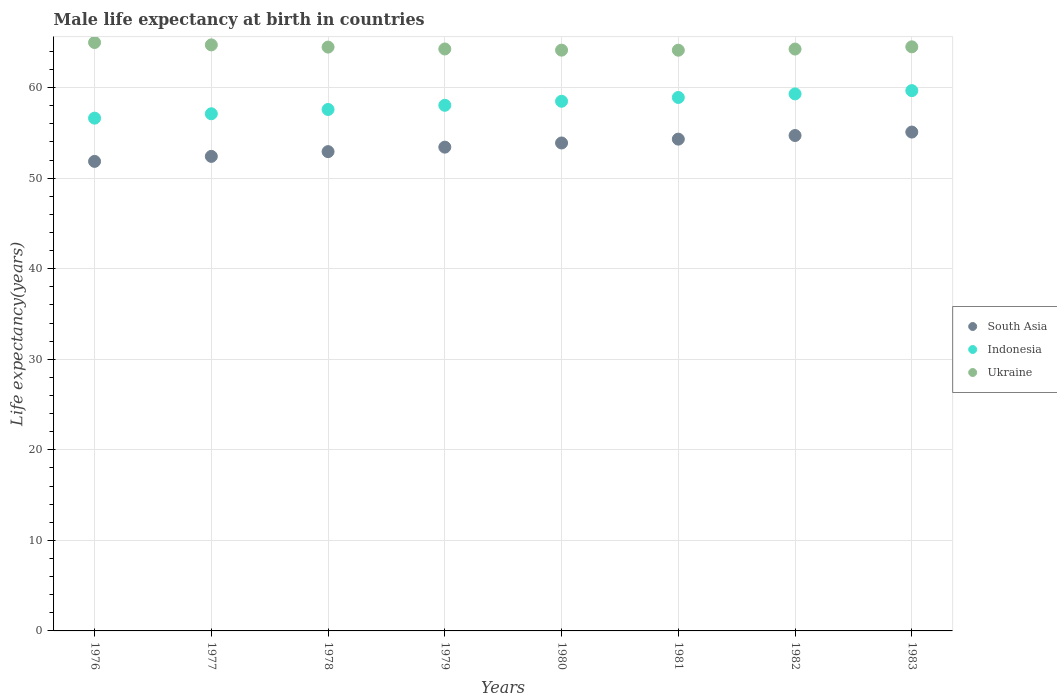How many different coloured dotlines are there?
Make the answer very short. 3. What is the male life expectancy at birth in Ukraine in 1981?
Your answer should be very brief. 64.12. Across all years, what is the maximum male life expectancy at birth in Indonesia?
Provide a short and direct response. 59.66. Across all years, what is the minimum male life expectancy at birth in Ukraine?
Provide a succinct answer. 64.12. What is the total male life expectancy at birth in South Asia in the graph?
Provide a short and direct response. 428.56. What is the difference between the male life expectancy at birth in Ukraine in 1979 and that in 1981?
Provide a short and direct response. 0.14. What is the difference between the male life expectancy at birth in Ukraine in 1983 and the male life expectancy at birth in Indonesia in 1982?
Ensure brevity in your answer.  5.2. What is the average male life expectancy at birth in Ukraine per year?
Offer a very short reply. 64.43. In the year 1977, what is the difference between the male life expectancy at birth in South Asia and male life expectancy at birth in Ukraine?
Provide a succinct answer. -12.31. In how many years, is the male life expectancy at birth in Ukraine greater than 38 years?
Provide a short and direct response. 8. What is the ratio of the male life expectancy at birth in Ukraine in 1979 to that in 1981?
Make the answer very short. 1. Is the male life expectancy at birth in Indonesia in 1980 less than that in 1981?
Your answer should be compact. Yes. Is the difference between the male life expectancy at birth in South Asia in 1979 and 1982 greater than the difference between the male life expectancy at birth in Ukraine in 1979 and 1982?
Your answer should be very brief. No. What is the difference between the highest and the second highest male life expectancy at birth in Ukraine?
Offer a terse response. 0.26. What is the difference between the highest and the lowest male life expectancy at birth in Ukraine?
Ensure brevity in your answer.  0.85. Is the sum of the male life expectancy at birth in Ukraine in 1976 and 1979 greater than the maximum male life expectancy at birth in Indonesia across all years?
Ensure brevity in your answer.  Yes. Is it the case that in every year, the sum of the male life expectancy at birth in Ukraine and male life expectancy at birth in South Asia  is greater than the male life expectancy at birth in Indonesia?
Offer a terse response. Yes. Does the male life expectancy at birth in Indonesia monotonically increase over the years?
Provide a short and direct response. Yes. How many years are there in the graph?
Your response must be concise. 8. Are the values on the major ticks of Y-axis written in scientific E-notation?
Give a very brief answer. No. Does the graph contain any zero values?
Your response must be concise. No. Does the graph contain grids?
Your answer should be compact. Yes. What is the title of the graph?
Ensure brevity in your answer.  Male life expectancy at birth in countries. Does "Romania" appear as one of the legend labels in the graph?
Ensure brevity in your answer.  No. What is the label or title of the X-axis?
Provide a short and direct response. Years. What is the label or title of the Y-axis?
Provide a short and direct response. Life expectancy(years). What is the Life expectancy(years) of South Asia in 1976?
Ensure brevity in your answer.  51.85. What is the Life expectancy(years) of Indonesia in 1976?
Your answer should be compact. 56.62. What is the Life expectancy(years) of Ukraine in 1976?
Ensure brevity in your answer.  64.97. What is the Life expectancy(years) in South Asia in 1977?
Ensure brevity in your answer.  52.4. What is the Life expectancy(years) of Indonesia in 1977?
Make the answer very short. 57.1. What is the Life expectancy(years) of Ukraine in 1977?
Keep it short and to the point. 64.71. What is the Life expectancy(years) of South Asia in 1978?
Provide a short and direct response. 52.92. What is the Life expectancy(years) in Indonesia in 1978?
Give a very brief answer. 57.58. What is the Life expectancy(years) in Ukraine in 1978?
Offer a terse response. 64.47. What is the Life expectancy(years) of South Asia in 1979?
Provide a short and direct response. 53.42. What is the Life expectancy(years) in Indonesia in 1979?
Offer a terse response. 58.04. What is the Life expectancy(years) of Ukraine in 1979?
Your answer should be compact. 64.26. What is the Life expectancy(years) in South Asia in 1980?
Provide a succinct answer. 53.88. What is the Life expectancy(years) in Indonesia in 1980?
Keep it short and to the point. 58.49. What is the Life expectancy(years) in Ukraine in 1980?
Ensure brevity in your answer.  64.13. What is the Life expectancy(years) in South Asia in 1981?
Keep it short and to the point. 54.3. What is the Life expectancy(years) in Indonesia in 1981?
Give a very brief answer. 58.91. What is the Life expectancy(years) of Ukraine in 1981?
Ensure brevity in your answer.  64.12. What is the Life expectancy(years) in South Asia in 1982?
Your answer should be compact. 54.7. What is the Life expectancy(years) in Indonesia in 1982?
Your response must be concise. 59.3. What is the Life expectancy(years) of Ukraine in 1982?
Your answer should be very brief. 64.25. What is the Life expectancy(years) of South Asia in 1983?
Provide a succinct answer. 55.08. What is the Life expectancy(years) of Indonesia in 1983?
Provide a succinct answer. 59.66. What is the Life expectancy(years) of Ukraine in 1983?
Make the answer very short. 64.5. Across all years, what is the maximum Life expectancy(years) of South Asia?
Provide a short and direct response. 55.08. Across all years, what is the maximum Life expectancy(years) in Indonesia?
Keep it short and to the point. 59.66. Across all years, what is the maximum Life expectancy(years) in Ukraine?
Your answer should be very brief. 64.97. Across all years, what is the minimum Life expectancy(years) in South Asia?
Provide a short and direct response. 51.85. Across all years, what is the minimum Life expectancy(years) of Indonesia?
Your answer should be very brief. 56.62. Across all years, what is the minimum Life expectancy(years) of Ukraine?
Ensure brevity in your answer.  64.12. What is the total Life expectancy(years) of South Asia in the graph?
Offer a terse response. 428.56. What is the total Life expectancy(years) in Indonesia in the graph?
Provide a succinct answer. 465.7. What is the total Life expectancy(years) in Ukraine in the graph?
Offer a terse response. 515.41. What is the difference between the Life expectancy(years) of South Asia in 1976 and that in 1977?
Provide a succinct answer. -0.55. What is the difference between the Life expectancy(years) of Indonesia in 1976 and that in 1977?
Make the answer very short. -0.48. What is the difference between the Life expectancy(years) of Ukraine in 1976 and that in 1977?
Provide a short and direct response. 0.26. What is the difference between the Life expectancy(years) of South Asia in 1976 and that in 1978?
Ensure brevity in your answer.  -1.08. What is the difference between the Life expectancy(years) in Indonesia in 1976 and that in 1978?
Your answer should be very brief. -0.96. What is the difference between the Life expectancy(years) in Ukraine in 1976 and that in 1978?
Your answer should be very brief. 0.51. What is the difference between the Life expectancy(years) of South Asia in 1976 and that in 1979?
Your answer should be very brief. -1.57. What is the difference between the Life expectancy(years) in Indonesia in 1976 and that in 1979?
Provide a short and direct response. -1.42. What is the difference between the Life expectancy(years) of Ukraine in 1976 and that in 1979?
Your answer should be very brief. 0.71. What is the difference between the Life expectancy(years) in South Asia in 1976 and that in 1980?
Provide a succinct answer. -2.03. What is the difference between the Life expectancy(years) of Indonesia in 1976 and that in 1980?
Offer a terse response. -1.86. What is the difference between the Life expectancy(years) of Ukraine in 1976 and that in 1980?
Offer a terse response. 0.84. What is the difference between the Life expectancy(years) of South Asia in 1976 and that in 1981?
Give a very brief answer. -2.46. What is the difference between the Life expectancy(years) in Indonesia in 1976 and that in 1981?
Ensure brevity in your answer.  -2.29. What is the difference between the Life expectancy(years) of Ukraine in 1976 and that in 1981?
Offer a very short reply. 0.85. What is the difference between the Life expectancy(years) in South Asia in 1976 and that in 1982?
Your answer should be very brief. -2.86. What is the difference between the Life expectancy(years) of Indonesia in 1976 and that in 1982?
Your answer should be compact. -2.68. What is the difference between the Life expectancy(years) of Ukraine in 1976 and that in 1982?
Give a very brief answer. 0.72. What is the difference between the Life expectancy(years) of South Asia in 1976 and that in 1983?
Make the answer very short. -3.24. What is the difference between the Life expectancy(years) of Indonesia in 1976 and that in 1983?
Ensure brevity in your answer.  -3.04. What is the difference between the Life expectancy(years) of Ukraine in 1976 and that in 1983?
Your response must be concise. 0.48. What is the difference between the Life expectancy(years) of South Asia in 1977 and that in 1978?
Ensure brevity in your answer.  -0.53. What is the difference between the Life expectancy(years) of Indonesia in 1977 and that in 1978?
Make the answer very short. -0.47. What is the difference between the Life expectancy(years) of Ukraine in 1977 and that in 1978?
Offer a terse response. 0.24. What is the difference between the Life expectancy(years) in South Asia in 1977 and that in 1979?
Offer a very short reply. -1.02. What is the difference between the Life expectancy(years) of Indonesia in 1977 and that in 1979?
Your answer should be compact. -0.94. What is the difference between the Life expectancy(years) of Ukraine in 1977 and that in 1979?
Make the answer very short. 0.45. What is the difference between the Life expectancy(years) in South Asia in 1977 and that in 1980?
Your answer should be very brief. -1.48. What is the difference between the Life expectancy(years) of Indonesia in 1977 and that in 1980?
Keep it short and to the point. -1.38. What is the difference between the Life expectancy(years) in Ukraine in 1977 and that in 1980?
Keep it short and to the point. 0.58. What is the difference between the Life expectancy(years) in South Asia in 1977 and that in 1981?
Offer a very short reply. -1.9. What is the difference between the Life expectancy(years) of Indonesia in 1977 and that in 1981?
Offer a terse response. -1.8. What is the difference between the Life expectancy(years) of Ukraine in 1977 and that in 1981?
Keep it short and to the point. 0.59. What is the difference between the Life expectancy(years) in South Asia in 1977 and that in 1982?
Give a very brief answer. -2.3. What is the difference between the Life expectancy(years) of Indonesia in 1977 and that in 1982?
Offer a terse response. -2.19. What is the difference between the Life expectancy(years) in Ukraine in 1977 and that in 1982?
Provide a short and direct response. 0.46. What is the difference between the Life expectancy(years) of South Asia in 1977 and that in 1983?
Provide a succinct answer. -2.69. What is the difference between the Life expectancy(years) in Indonesia in 1977 and that in 1983?
Provide a succinct answer. -2.56. What is the difference between the Life expectancy(years) in Ukraine in 1977 and that in 1983?
Make the answer very short. 0.21. What is the difference between the Life expectancy(years) in South Asia in 1978 and that in 1979?
Provide a short and direct response. -0.49. What is the difference between the Life expectancy(years) in Indonesia in 1978 and that in 1979?
Make the answer very short. -0.46. What is the difference between the Life expectancy(years) in Ukraine in 1978 and that in 1979?
Your response must be concise. 0.21. What is the difference between the Life expectancy(years) of South Asia in 1978 and that in 1980?
Your answer should be very brief. -0.96. What is the difference between the Life expectancy(years) of Indonesia in 1978 and that in 1980?
Ensure brevity in your answer.  -0.91. What is the difference between the Life expectancy(years) in Ukraine in 1978 and that in 1980?
Ensure brevity in your answer.  0.34. What is the difference between the Life expectancy(years) in South Asia in 1978 and that in 1981?
Keep it short and to the point. -1.38. What is the difference between the Life expectancy(years) of Indonesia in 1978 and that in 1981?
Your answer should be very brief. -1.33. What is the difference between the Life expectancy(years) in Ukraine in 1978 and that in 1981?
Your answer should be very brief. 0.34. What is the difference between the Life expectancy(years) of South Asia in 1978 and that in 1982?
Your answer should be compact. -1.78. What is the difference between the Life expectancy(years) of Indonesia in 1978 and that in 1982?
Offer a very short reply. -1.72. What is the difference between the Life expectancy(years) of Ukraine in 1978 and that in 1982?
Provide a short and direct response. 0.22. What is the difference between the Life expectancy(years) of South Asia in 1978 and that in 1983?
Give a very brief answer. -2.16. What is the difference between the Life expectancy(years) in Indonesia in 1978 and that in 1983?
Provide a short and direct response. -2.08. What is the difference between the Life expectancy(years) of Ukraine in 1978 and that in 1983?
Your response must be concise. -0.03. What is the difference between the Life expectancy(years) in South Asia in 1979 and that in 1980?
Ensure brevity in your answer.  -0.46. What is the difference between the Life expectancy(years) of Indonesia in 1979 and that in 1980?
Provide a succinct answer. -0.45. What is the difference between the Life expectancy(years) of Ukraine in 1979 and that in 1980?
Your answer should be compact. 0.13. What is the difference between the Life expectancy(years) in South Asia in 1979 and that in 1981?
Ensure brevity in your answer.  -0.88. What is the difference between the Life expectancy(years) in Indonesia in 1979 and that in 1981?
Your answer should be compact. -0.86. What is the difference between the Life expectancy(years) of Ukraine in 1979 and that in 1981?
Provide a short and direct response. 0.14. What is the difference between the Life expectancy(years) of South Asia in 1979 and that in 1982?
Your answer should be very brief. -1.28. What is the difference between the Life expectancy(years) in Indonesia in 1979 and that in 1982?
Your answer should be very brief. -1.26. What is the difference between the Life expectancy(years) in Ukraine in 1979 and that in 1982?
Keep it short and to the point. 0.01. What is the difference between the Life expectancy(years) in South Asia in 1979 and that in 1983?
Your answer should be very brief. -1.67. What is the difference between the Life expectancy(years) of Indonesia in 1979 and that in 1983?
Provide a short and direct response. -1.62. What is the difference between the Life expectancy(years) of Ukraine in 1979 and that in 1983?
Offer a very short reply. -0.24. What is the difference between the Life expectancy(years) in South Asia in 1980 and that in 1981?
Offer a terse response. -0.42. What is the difference between the Life expectancy(years) in Indonesia in 1980 and that in 1981?
Provide a succinct answer. -0.42. What is the difference between the Life expectancy(years) in Ukraine in 1980 and that in 1981?
Offer a terse response. 0.01. What is the difference between the Life expectancy(years) of South Asia in 1980 and that in 1982?
Offer a very short reply. -0.82. What is the difference between the Life expectancy(years) of Indonesia in 1980 and that in 1982?
Give a very brief answer. -0.81. What is the difference between the Life expectancy(years) in Ukraine in 1980 and that in 1982?
Your answer should be compact. -0.12. What is the difference between the Life expectancy(years) in South Asia in 1980 and that in 1983?
Keep it short and to the point. -1.2. What is the difference between the Life expectancy(years) in Indonesia in 1980 and that in 1983?
Your answer should be compact. -1.18. What is the difference between the Life expectancy(years) of Ukraine in 1980 and that in 1983?
Provide a short and direct response. -0.37. What is the difference between the Life expectancy(years) of South Asia in 1981 and that in 1982?
Provide a short and direct response. -0.4. What is the difference between the Life expectancy(years) of Indonesia in 1981 and that in 1982?
Offer a very short reply. -0.39. What is the difference between the Life expectancy(years) in Ukraine in 1981 and that in 1982?
Provide a succinct answer. -0.13. What is the difference between the Life expectancy(years) in South Asia in 1981 and that in 1983?
Keep it short and to the point. -0.78. What is the difference between the Life expectancy(years) of Indonesia in 1981 and that in 1983?
Your answer should be compact. -0.76. What is the difference between the Life expectancy(years) of Ukraine in 1981 and that in 1983?
Provide a short and direct response. -0.37. What is the difference between the Life expectancy(years) in South Asia in 1982 and that in 1983?
Keep it short and to the point. -0.38. What is the difference between the Life expectancy(years) of Indonesia in 1982 and that in 1983?
Your answer should be very brief. -0.36. What is the difference between the Life expectancy(years) in Ukraine in 1982 and that in 1983?
Give a very brief answer. -0.25. What is the difference between the Life expectancy(years) in South Asia in 1976 and the Life expectancy(years) in Indonesia in 1977?
Ensure brevity in your answer.  -5.26. What is the difference between the Life expectancy(years) of South Asia in 1976 and the Life expectancy(years) of Ukraine in 1977?
Your answer should be very brief. -12.86. What is the difference between the Life expectancy(years) of Indonesia in 1976 and the Life expectancy(years) of Ukraine in 1977?
Your answer should be very brief. -8.09. What is the difference between the Life expectancy(years) of South Asia in 1976 and the Life expectancy(years) of Indonesia in 1978?
Your answer should be very brief. -5.73. What is the difference between the Life expectancy(years) in South Asia in 1976 and the Life expectancy(years) in Ukraine in 1978?
Offer a terse response. -12.62. What is the difference between the Life expectancy(years) of Indonesia in 1976 and the Life expectancy(years) of Ukraine in 1978?
Ensure brevity in your answer.  -7.85. What is the difference between the Life expectancy(years) of South Asia in 1976 and the Life expectancy(years) of Indonesia in 1979?
Provide a succinct answer. -6.19. What is the difference between the Life expectancy(years) in South Asia in 1976 and the Life expectancy(years) in Ukraine in 1979?
Your response must be concise. -12.41. What is the difference between the Life expectancy(years) of Indonesia in 1976 and the Life expectancy(years) of Ukraine in 1979?
Your answer should be compact. -7.64. What is the difference between the Life expectancy(years) in South Asia in 1976 and the Life expectancy(years) in Indonesia in 1980?
Offer a very short reply. -6.64. What is the difference between the Life expectancy(years) of South Asia in 1976 and the Life expectancy(years) of Ukraine in 1980?
Provide a short and direct response. -12.28. What is the difference between the Life expectancy(years) of Indonesia in 1976 and the Life expectancy(years) of Ukraine in 1980?
Ensure brevity in your answer.  -7.51. What is the difference between the Life expectancy(years) in South Asia in 1976 and the Life expectancy(years) in Indonesia in 1981?
Offer a very short reply. -7.06. What is the difference between the Life expectancy(years) of South Asia in 1976 and the Life expectancy(years) of Ukraine in 1981?
Your answer should be very brief. -12.28. What is the difference between the Life expectancy(years) of Indonesia in 1976 and the Life expectancy(years) of Ukraine in 1981?
Make the answer very short. -7.5. What is the difference between the Life expectancy(years) of South Asia in 1976 and the Life expectancy(years) of Indonesia in 1982?
Provide a succinct answer. -7.45. What is the difference between the Life expectancy(years) of South Asia in 1976 and the Life expectancy(years) of Ukraine in 1982?
Give a very brief answer. -12.4. What is the difference between the Life expectancy(years) in Indonesia in 1976 and the Life expectancy(years) in Ukraine in 1982?
Offer a terse response. -7.63. What is the difference between the Life expectancy(years) of South Asia in 1976 and the Life expectancy(years) of Indonesia in 1983?
Your answer should be compact. -7.81. What is the difference between the Life expectancy(years) in South Asia in 1976 and the Life expectancy(years) in Ukraine in 1983?
Offer a terse response. -12.65. What is the difference between the Life expectancy(years) of Indonesia in 1976 and the Life expectancy(years) of Ukraine in 1983?
Your response must be concise. -7.88. What is the difference between the Life expectancy(years) of South Asia in 1977 and the Life expectancy(years) of Indonesia in 1978?
Provide a short and direct response. -5.18. What is the difference between the Life expectancy(years) of South Asia in 1977 and the Life expectancy(years) of Ukraine in 1978?
Provide a short and direct response. -12.07. What is the difference between the Life expectancy(years) of Indonesia in 1977 and the Life expectancy(years) of Ukraine in 1978?
Offer a terse response. -7.36. What is the difference between the Life expectancy(years) in South Asia in 1977 and the Life expectancy(years) in Indonesia in 1979?
Your response must be concise. -5.64. What is the difference between the Life expectancy(years) in South Asia in 1977 and the Life expectancy(years) in Ukraine in 1979?
Offer a terse response. -11.86. What is the difference between the Life expectancy(years) of Indonesia in 1977 and the Life expectancy(years) of Ukraine in 1979?
Make the answer very short. -7.16. What is the difference between the Life expectancy(years) of South Asia in 1977 and the Life expectancy(years) of Indonesia in 1980?
Make the answer very short. -6.09. What is the difference between the Life expectancy(years) in South Asia in 1977 and the Life expectancy(years) in Ukraine in 1980?
Keep it short and to the point. -11.73. What is the difference between the Life expectancy(years) in Indonesia in 1977 and the Life expectancy(years) in Ukraine in 1980?
Ensure brevity in your answer.  -7.03. What is the difference between the Life expectancy(years) of South Asia in 1977 and the Life expectancy(years) of Indonesia in 1981?
Provide a succinct answer. -6.51. What is the difference between the Life expectancy(years) of South Asia in 1977 and the Life expectancy(years) of Ukraine in 1981?
Make the answer very short. -11.72. What is the difference between the Life expectancy(years) in Indonesia in 1977 and the Life expectancy(years) in Ukraine in 1981?
Offer a terse response. -7.02. What is the difference between the Life expectancy(years) of South Asia in 1977 and the Life expectancy(years) of Indonesia in 1982?
Your answer should be compact. -6.9. What is the difference between the Life expectancy(years) in South Asia in 1977 and the Life expectancy(years) in Ukraine in 1982?
Give a very brief answer. -11.85. What is the difference between the Life expectancy(years) of Indonesia in 1977 and the Life expectancy(years) of Ukraine in 1982?
Make the answer very short. -7.15. What is the difference between the Life expectancy(years) of South Asia in 1977 and the Life expectancy(years) of Indonesia in 1983?
Offer a terse response. -7.26. What is the difference between the Life expectancy(years) in South Asia in 1977 and the Life expectancy(years) in Ukraine in 1983?
Ensure brevity in your answer.  -12.1. What is the difference between the Life expectancy(years) of Indonesia in 1977 and the Life expectancy(years) of Ukraine in 1983?
Your answer should be very brief. -7.39. What is the difference between the Life expectancy(years) in South Asia in 1978 and the Life expectancy(years) in Indonesia in 1979?
Offer a very short reply. -5.12. What is the difference between the Life expectancy(years) in South Asia in 1978 and the Life expectancy(years) in Ukraine in 1979?
Your answer should be compact. -11.34. What is the difference between the Life expectancy(years) in Indonesia in 1978 and the Life expectancy(years) in Ukraine in 1979?
Your response must be concise. -6.68. What is the difference between the Life expectancy(years) of South Asia in 1978 and the Life expectancy(years) of Indonesia in 1980?
Provide a succinct answer. -5.56. What is the difference between the Life expectancy(years) of South Asia in 1978 and the Life expectancy(years) of Ukraine in 1980?
Ensure brevity in your answer.  -11.21. What is the difference between the Life expectancy(years) in Indonesia in 1978 and the Life expectancy(years) in Ukraine in 1980?
Your answer should be compact. -6.55. What is the difference between the Life expectancy(years) of South Asia in 1978 and the Life expectancy(years) of Indonesia in 1981?
Keep it short and to the point. -5.98. What is the difference between the Life expectancy(years) of South Asia in 1978 and the Life expectancy(years) of Ukraine in 1981?
Make the answer very short. -11.2. What is the difference between the Life expectancy(years) in Indonesia in 1978 and the Life expectancy(years) in Ukraine in 1981?
Make the answer very short. -6.54. What is the difference between the Life expectancy(years) in South Asia in 1978 and the Life expectancy(years) in Indonesia in 1982?
Make the answer very short. -6.37. What is the difference between the Life expectancy(years) of South Asia in 1978 and the Life expectancy(years) of Ukraine in 1982?
Make the answer very short. -11.33. What is the difference between the Life expectancy(years) in Indonesia in 1978 and the Life expectancy(years) in Ukraine in 1982?
Provide a short and direct response. -6.67. What is the difference between the Life expectancy(years) in South Asia in 1978 and the Life expectancy(years) in Indonesia in 1983?
Give a very brief answer. -6.74. What is the difference between the Life expectancy(years) of South Asia in 1978 and the Life expectancy(years) of Ukraine in 1983?
Keep it short and to the point. -11.57. What is the difference between the Life expectancy(years) in Indonesia in 1978 and the Life expectancy(years) in Ukraine in 1983?
Give a very brief answer. -6.92. What is the difference between the Life expectancy(years) of South Asia in 1979 and the Life expectancy(years) of Indonesia in 1980?
Ensure brevity in your answer.  -5.07. What is the difference between the Life expectancy(years) in South Asia in 1979 and the Life expectancy(years) in Ukraine in 1980?
Ensure brevity in your answer.  -10.71. What is the difference between the Life expectancy(years) of Indonesia in 1979 and the Life expectancy(years) of Ukraine in 1980?
Offer a very short reply. -6.09. What is the difference between the Life expectancy(years) in South Asia in 1979 and the Life expectancy(years) in Indonesia in 1981?
Keep it short and to the point. -5.49. What is the difference between the Life expectancy(years) of South Asia in 1979 and the Life expectancy(years) of Ukraine in 1981?
Your answer should be compact. -10.7. What is the difference between the Life expectancy(years) in Indonesia in 1979 and the Life expectancy(years) in Ukraine in 1981?
Ensure brevity in your answer.  -6.08. What is the difference between the Life expectancy(years) of South Asia in 1979 and the Life expectancy(years) of Indonesia in 1982?
Give a very brief answer. -5.88. What is the difference between the Life expectancy(years) in South Asia in 1979 and the Life expectancy(years) in Ukraine in 1982?
Your answer should be very brief. -10.83. What is the difference between the Life expectancy(years) in Indonesia in 1979 and the Life expectancy(years) in Ukraine in 1982?
Keep it short and to the point. -6.21. What is the difference between the Life expectancy(years) of South Asia in 1979 and the Life expectancy(years) of Indonesia in 1983?
Ensure brevity in your answer.  -6.24. What is the difference between the Life expectancy(years) in South Asia in 1979 and the Life expectancy(years) in Ukraine in 1983?
Offer a terse response. -11.08. What is the difference between the Life expectancy(years) in Indonesia in 1979 and the Life expectancy(years) in Ukraine in 1983?
Offer a very short reply. -6.46. What is the difference between the Life expectancy(years) in South Asia in 1980 and the Life expectancy(years) in Indonesia in 1981?
Your answer should be compact. -5.03. What is the difference between the Life expectancy(years) in South Asia in 1980 and the Life expectancy(years) in Ukraine in 1981?
Offer a very short reply. -10.24. What is the difference between the Life expectancy(years) of Indonesia in 1980 and the Life expectancy(years) of Ukraine in 1981?
Ensure brevity in your answer.  -5.64. What is the difference between the Life expectancy(years) of South Asia in 1980 and the Life expectancy(years) of Indonesia in 1982?
Provide a short and direct response. -5.42. What is the difference between the Life expectancy(years) of South Asia in 1980 and the Life expectancy(years) of Ukraine in 1982?
Keep it short and to the point. -10.37. What is the difference between the Life expectancy(years) in Indonesia in 1980 and the Life expectancy(years) in Ukraine in 1982?
Provide a short and direct response. -5.76. What is the difference between the Life expectancy(years) of South Asia in 1980 and the Life expectancy(years) of Indonesia in 1983?
Keep it short and to the point. -5.78. What is the difference between the Life expectancy(years) in South Asia in 1980 and the Life expectancy(years) in Ukraine in 1983?
Provide a short and direct response. -10.62. What is the difference between the Life expectancy(years) in Indonesia in 1980 and the Life expectancy(years) in Ukraine in 1983?
Offer a terse response. -6.01. What is the difference between the Life expectancy(years) in South Asia in 1981 and the Life expectancy(years) in Indonesia in 1982?
Your response must be concise. -4.99. What is the difference between the Life expectancy(years) in South Asia in 1981 and the Life expectancy(years) in Ukraine in 1982?
Your answer should be compact. -9.95. What is the difference between the Life expectancy(years) in Indonesia in 1981 and the Life expectancy(years) in Ukraine in 1982?
Your answer should be compact. -5.34. What is the difference between the Life expectancy(years) of South Asia in 1981 and the Life expectancy(years) of Indonesia in 1983?
Give a very brief answer. -5.36. What is the difference between the Life expectancy(years) in South Asia in 1981 and the Life expectancy(years) in Ukraine in 1983?
Keep it short and to the point. -10.19. What is the difference between the Life expectancy(years) in Indonesia in 1981 and the Life expectancy(years) in Ukraine in 1983?
Your answer should be compact. -5.59. What is the difference between the Life expectancy(years) in South Asia in 1982 and the Life expectancy(years) in Indonesia in 1983?
Offer a terse response. -4.96. What is the difference between the Life expectancy(years) of South Asia in 1982 and the Life expectancy(years) of Ukraine in 1983?
Your answer should be compact. -9.79. What is the difference between the Life expectancy(years) of Indonesia in 1982 and the Life expectancy(years) of Ukraine in 1983?
Ensure brevity in your answer.  -5.2. What is the average Life expectancy(years) in South Asia per year?
Ensure brevity in your answer.  53.57. What is the average Life expectancy(years) in Indonesia per year?
Give a very brief answer. 58.21. What is the average Life expectancy(years) of Ukraine per year?
Provide a succinct answer. 64.43. In the year 1976, what is the difference between the Life expectancy(years) of South Asia and Life expectancy(years) of Indonesia?
Provide a short and direct response. -4.77. In the year 1976, what is the difference between the Life expectancy(years) of South Asia and Life expectancy(years) of Ukraine?
Provide a succinct answer. -13.13. In the year 1976, what is the difference between the Life expectancy(years) of Indonesia and Life expectancy(years) of Ukraine?
Your answer should be compact. -8.35. In the year 1977, what is the difference between the Life expectancy(years) in South Asia and Life expectancy(years) in Indonesia?
Your answer should be compact. -4.71. In the year 1977, what is the difference between the Life expectancy(years) of South Asia and Life expectancy(years) of Ukraine?
Your answer should be compact. -12.31. In the year 1977, what is the difference between the Life expectancy(years) of Indonesia and Life expectancy(years) of Ukraine?
Provide a short and direct response. -7.61. In the year 1978, what is the difference between the Life expectancy(years) of South Asia and Life expectancy(years) of Indonesia?
Your answer should be very brief. -4.65. In the year 1978, what is the difference between the Life expectancy(years) of South Asia and Life expectancy(years) of Ukraine?
Keep it short and to the point. -11.54. In the year 1978, what is the difference between the Life expectancy(years) of Indonesia and Life expectancy(years) of Ukraine?
Make the answer very short. -6.89. In the year 1979, what is the difference between the Life expectancy(years) of South Asia and Life expectancy(years) of Indonesia?
Your answer should be very brief. -4.62. In the year 1979, what is the difference between the Life expectancy(years) in South Asia and Life expectancy(years) in Ukraine?
Give a very brief answer. -10.84. In the year 1979, what is the difference between the Life expectancy(years) in Indonesia and Life expectancy(years) in Ukraine?
Ensure brevity in your answer.  -6.22. In the year 1980, what is the difference between the Life expectancy(years) in South Asia and Life expectancy(years) in Indonesia?
Provide a short and direct response. -4.61. In the year 1980, what is the difference between the Life expectancy(years) of South Asia and Life expectancy(years) of Ukraine?
Offer a terse response. -10.25. In the year 1980, what is the difference between the Life expectancy(years) of Indonesia and Life expectancy(years) of Ukraine?
Your answer should be compact. -5.64. In the year 1981, what is the difference between the Life expectancy(years) of South Asia and Life expectancy(years) of Indonesia?
Offer a terse response. -4.6. In the year 1981, what is the difference between the Life expectancy(years) of South Asia and Life expectancy(years) of Ukraine?
Your response must be concise. -9.82. In the year 1981, what is the difference between the Life expectancy(years) in Indonesia and Life expectancy(years) in Ukraine?
Provide a short and direct response. -5.22. In the year 1982, what is the difference between the Life expectancy(years) of South Asia and Life expectancy(years) of Indonesia?
Give a very brief answer. -4.59. In the year 1982, what is the difference between the Life expectancy(years) of South Asia and Life expectancy(years) of Ukraine?
Provide a succinct answer. -9.55. In the year 1982, what is the difference between the Life expectancy(years) in Indonesia and Life expectancy(years) in Ukraine?
Offer a very short reply. -4.95. In the year 1983, what is the difference between the Life expectancy(years) of South Asia and Life expectancy(years) of Indonesia?
Keep it short and to the point. -4.58. In the year 1983, what is the difference between the Life expectancy(years) of South Asia and Life expectancy(years) of Ukraine?
Offer a very short reply. -9.41. In the year 1983, what is the difference between the Life expectancy(years) in Indonesia and Life expectancy(years) in Ukraine?
Offer a very short reply. -4.84. What is the ratio of the Life expectancy(years) of South Asia in 1976 to that in 1978?
Offer a very short reply. 0.98. What is the ratio of the Life expectancy(years) in Indonesia in 1976 to that in 1978?
Ensure brevity in your answer.  0.98. What is the ratio of the Life expectancy(years) of South Asia in 1976 to that in 1979?
Provide a succinct answer. 0.97. What is the ratio of the Life expectancy(years) in Indonesia in 1976 to that in 1979?
Provide a short and direct response. 0.98. What is the ratio of the Life expectancy(years) of Ukraine in 1976 to that in 1979?
Provide a short and direct response. 1.01. What is the ratio of the Life expectancy(years) of South Asia in 1976 to that in 1980?
Ensure brevity in your answer.  0.96. What is the ratio of the Life expectancy(years) in Indonesia in 1976 to that in 1980?
Ensure brevity in your answer.  0.97. What is the ratio of the Life expectancy(years) in Ukraine in 1976 to that in 1980?
Offer a very short reply. 1.01. What is the ratio of the Life expectancy(years) of South Asia in 1976 to that in 1981?
Provide a succinct answer. 0.95. What is the ratio of the Life expectancy(years) in Indonesia in 1976 to that in 1981?
Offer a terse response. 0.96. What is the ratio of the Life expectancy(years) of Ukraine in 1976 to that in 1981?
Ensure brevity in your answer.  1.01. What is the ratio of the Life expectancy(years) in South Asia in 1976 to that in 1982?
Provide a short and direct response. 0.95. What is the ratio of the Life expectancy(years) in Indonesia in 1976 to that in 1982?
Make the answer very short. 0.95. What is the ratio of the Life expectancy(years) of Ukraine in 1976 to that in 1982?
Provide a short and direct response. 1.01. What is the ratio of the Life expectancy(years) in Indonesia in 1976 to that in 1983?
Make the answer very short. 0.95. What is the ratio of the Life expectancy(years) of Ukraine in 1976 to that in 1983?
Provide a short and direct response. 1.01. What is the ratio of the Life expectancy(years) of Indonesia in 1977 to that in 1978?
Provide a short and direct response. 0.99. What is the ratio of the Life expectancy(years) in South Asia in 1977 to that in 1979?
Give a very brief answer. 0.98. What is the ratio of the Life expectancy(years) in Indonesia in 1977 to that in 1979?
Offer a terse response. 0.98. What is the ratio of the Life expectancy(years) of South Asia in 1977 to that in 1980?
Your answer should be compact. 0.97. What is the ratio of the Life expectancy(years) of Indonesia in 1977 to that in 1980?
Make the answer very short. 0.98. What is the ratio of the Life expectancy(years) of Ukraine in 1977 to that in 1980?
Your answer should be very brief. 1.01. What is the ratio of the Life expectancy(years) of South Asia in 1977 to that in 1981?
Make the answer very short. 0.96. What is the ratio of the Life expectancy(years) in Indonesia in 1977 to that in 1981?
Make the answer very short. 0.97. What is the ratio of the Life expectancy(years) of Ukraine in 1977 to that in 1981?
Ensure brevity in your answer.  1.01. What is the ratio of the Life expectancy(years) of South Asia in 1977 to that in 1982?
Provide a succinct answer. 0.96. What is the ratio of the Life expectancy(years) of South Asia in 1977 to that in 1983?
Make the answer very short. 0.95. What is the ratio of the Life expectancy(years) of Indonesia in 1977 to that in 1983?
Keep it short and to the point. 0.96. What is the ratio of the Life expectancy(years) in Ukraine in 1977 to that in 1983?
Provide a short and direct response. 1. What is the ratio of the Life expectancy(years) in South Asia in 1978 to that in 1979?
Give a very brief answer. 0.99. What is the ratio of the Life expectancy(years) in South Asia in 1978 to that in 1980?
Provide a short and direct response. 0.98. What is the ratio of the Life expectancy(years) in Indonesia in 1978 to that in 1980?
Your response must be concise. 0.98. What is the ratio of the Life expectancy(years) in South Asia in 1978 to that in 1981?
Provide a succinct answer. 0.97. What is the ratio of the Life expectancy(years) in Indonesia in 1978 to that in 1981?
Your answer should be very brief. 0.98. What is the ratio of the Life expectancy(years) in South Asia in 1978 to that in 1982?
Provide a succinct answer. 0.97. What is the ratio of the Life expectancy(years) of Ukraine in 1978 to that in 1982?
Make the answer very short. 1. What is the ratio of the Life expectancy(years) of South Asia in 1978 to that in 1983?
Give a very brief answer. 0.96. What is the ratio of the Life expectancy(years) of Indonesia in 1978 to that in 1983?
Offer a terse response. 0.97. What is the ratio of the Life expectancy(years) of Ukraine in 1978 to that in 1983?
Make the answer very short. 1. What is the ratio of the Life expectancy(years) in South Asia in 1979 to that in 1981?
Your response must be concise. 0.98. What is the ratio of the Life expectancy(years) of South Asia in 1979 to that in 1982?
Give a very brief answer. 0.98. What is the ratio of the Life expectancy(years) of Indonesia in 1979 to that in 1982?
Offer a terse response. 0.98. What is the ratio of the Life expectancy(years) of South Asia in 1979 to that in 1983?
Give a very brief answer. 0.97. What is the ratio of the Life expectancy(years) in Indonesia in 1979 to that in 1983?
Offer a terse response. 0.97. What is the ratio of the Life expectancy(years) in Ukraine in 1979 to that in 1983?
Provide a short and direct response. 1. What is the ratio of the Life expectancy(years) in South Asia in 1980 to that in 1981?
Keep it short and to the point. 0.99. What is the ratio of the Life expectancy(years) in Indonesia in 1980 to that in 1981?
Offer a very short reply. 0.99. What is the ratio of the Life expectancy(years) in South Asia in 1980 to that in 1982?
Your response must be concise. 0.98. What is the ratio of the Life expectancy(years) of Indonesia in 1980 to that in 1982?
Your answer should be very brief. 0.99. What is the ratio of the Life expectancy(years) of Ukraine in 1980 to that in 1982?
Give a very brief answer. 1. What is the ratio of the Life expectancy(years) of South Asia in 1980 to that in 1983?
Provide a succinct answer. 0.98. What is the ratio of the Life expectancy(years) in Indonesia in 1980 to that in 1983?
Make the answer very short. 0.98. What is the ratio of the Life expectancy(years) of South Asia in 1981 to that in 1982?
Your answer should be very brief. 0.99. What is the ratio of the Life expectancy(years) in Indonesia in 1981 to that in 1982?
Provide a short and direct response. 0.99. What is the ratio of the Life expectancy(years) of Ukraine in 1981 to that in 1982?
Ensure brevity in your answer.  1. What is the ratio of the Life expectancy(years) in South Asia in 1981 to that in 1983?
Provide a succinct answer. 0.99. What is the ratio of the Life expectancy(years) of Indonesia in 1981 to that in 1983?
Ensure brevity in your answer.  0.99. What is the difference between the highest and the second highest Life expectancy(years) in South Asia?
Provide a succinct answer. 0.38. What is the difference between the highest and the second highest Life expectancy(years) of Indonesia?
Provide a succinct answer. 0.36. What is the difference between the highest and the second highest Life expectancy(years) in Ukraine?
Ensure brevity in your answer.  0.26. What is the difference between the highest and the lowest Life expectancy(years) in South Asia?
Offer a very short reply. 3.24. What is the difference between the highest and the lowest Life expectancy(years) in Indonesia?
Make the answer very short. 3.04. What is the difference between the highest and the lowest Life expectancy(years) of Ukraine?
Keep it short and to the point. 0.85. 